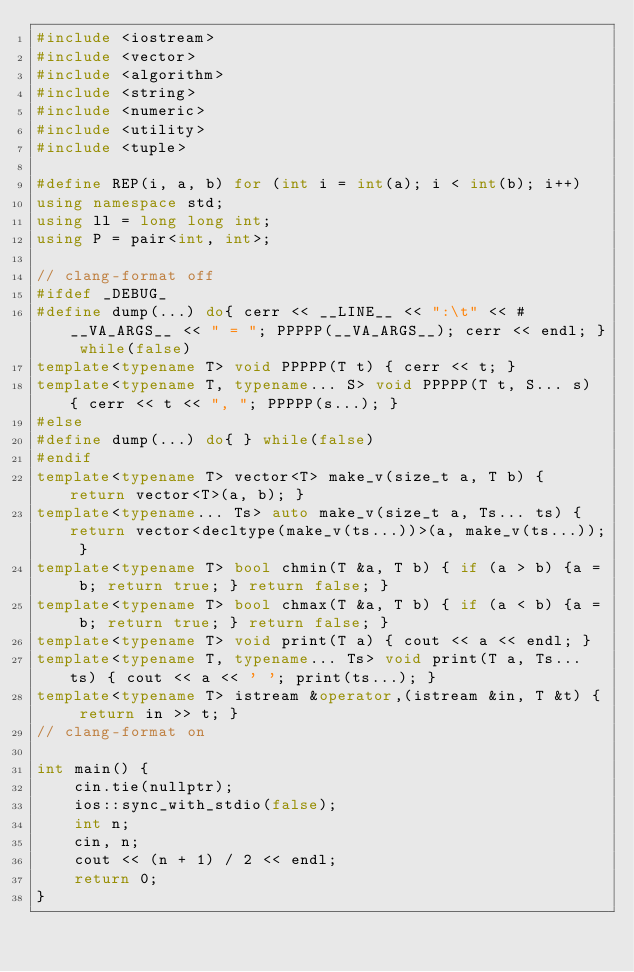Convert code to text. <code><loc_0><loc_0><loc_500><loc_500><_C++_>#include <iostream>
#include <vector>
#include <algorithm>
#include <string>
#include <numeric>
#include <utility>
#include <tuple>

#define REP(i, a, b) for (int i = int(a); i < int(b); i++)
using namespace std;
using ll = long long int;
using P = pair<int, int>;

// clang-format off
#ifdef _DEBUG_
#define dump(...) do{ cerr << __LINE__ << ":\t" << #__VA_ARGS__ << " = "; PPPPP(__VA_ARGS__); cerr << endl; } while(false)
template<typename T> void PPPPP(T t) { cerr << t; }
template<typename T, typename... S> void PPPPP(T t, S... s) { cerr << t << ", "; PPPPP(s...); }
#else
#define dump(...) do{ } while(false)
#endif
template<typename T> vector<T> make_v(size_t a, T b) { return vector<T>(a, b); }
template<typename... Ts> auto make_v(size_t a, Ts... ts) { return vector<decltype(make_v(ts...))>(a, make_v(ts...)); }
template<typename T> bool chmin(T &a, T b) { if (a > b) {a = b; return true; } return false; }
template<typename T> bool chmax(T &a, T b) { if (a < b) {a = b; return true; } return false; }
template<typename T> void print(T a) { cout << a << endl; }
template<typename T, typename... Ts> void print(T a, Ts... ts) { cout << a << ' '; print(ts...); }
template<typename T> istream &operator,(istream &in, T &t) { return in >> t; }
// clang-format on

int main() {
    cin.tie(nullptr);
    ios::sync_with_stdio(false);
    int n;
    cin, n;
    cout << (n + 1) / 2 << endl;
    return 0;
}
</code> 